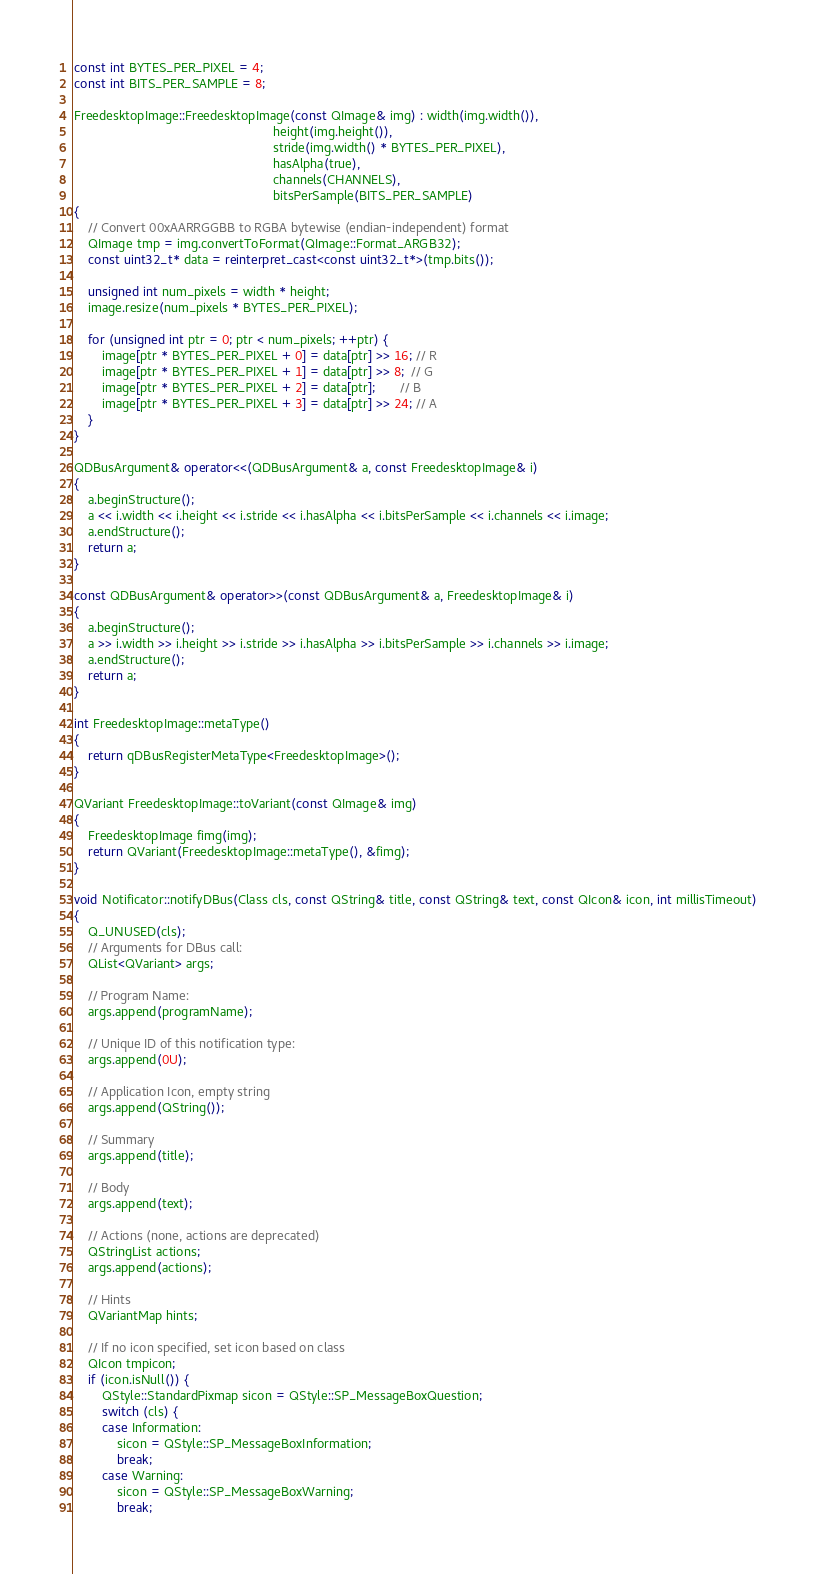Convert code to text. <code><loc_0><loc_0><loc_500><loc_500><_C++_>const int BYTES_PER_PIXEL = 4;
const int BITS_PER_SAMPLE = 8;

FreedesktopImage::FreedesktopImage(const QImage& img) : width(img.width()),
                                                        height(img.height()),
                                                        stride(img.width() * BYTES_PER_PIXEL),
                                                        hasAlpha(true),
                                                        channels(CHANNELS),
                                                        bitsPerSample(BITS_PER_SAMPLE)
{
    // Convert 00xAARRGGBB to RGBA bytewise (endian-independent) format
    QImage tmp = img.convertToFormat(QImage::Format_ARGB32);
    const uint32_t* data = reinterpret_cast<const uint32_t*>(tmp.bits());

    unsigned int num_pixels = width * height;
    image.resize(num_pixels * BYTES_PER_PIXEL);

    for (unsigned int ptr = 0; ptr < num_pixels; ++ptr) {
        image[ptr * BYTES_PER_PIXEL + 0] = data[ptr] >> 16; // R
        image[ptr * BYTES_PER_PIXEL + 1] = data[ptr] >> 8;  // G
        image[ptr * BYTES_PER_PIXEL + 2] = data[ptr];       // B
        image[ptr * BYTES_PER_PIXEL + 3] = data[ptr] >> 24; // A
    }
}

QDBusArgument& operator<<(QDBusArgument& a, const FreedesktopImage& i)
{
    a.beginStructure();
    a << i.width << i.height << i.stride << i.hasAlpha << i.bitsPerSample << i.channels << i.image;
    a.endStructure();
    return a;
}

const QDBusArgument& operator>>(const QDBusArgument& a, FreedesktopImage& i)
{
    a.beginStructure();
    a >> i.width >> i.height >> i.stride >> i.hasAlpha >> i.bitsPerSample >> i.channels >> i.image;
    a.endStructure();
    return a;
}

int FreedesktopImage::metaType()
{
    return qDBusRegisterMetaType<FreedesktopImage>();
}

QVariant FreedesktopImage::toVariant(const QImage& img)
{
    FreedesktopImage fimg(img);
    return QVariant(FreedesktopImage::metaType(), &fimg);
}

void Notificator::notifyDBus(Class cls, const QString& title, const QString& text, const QIcon& icon, int millisTimeout)
{
    Q_UNUSED(cls);
    // Arguments for DBus call:
    QList<QVariant> args;

    // Program Name:
    args.append(programName);

    // Unique ID of this notification type:
    args.append(0U);

    // Application Icon, empty string
    args.append(QString());

    // Summary
    args.append(title);

    // Body
    args.append(text);

    // Actions (none, actions are deprecated)
    QStringList actions;
    args.append(actions);

    // Hints
    QVariantMap hints;

    // If no icon specified, set icon based on class
    QIcon tmpicon;
    if (icon.isNull()) {
        QStyle::StandardPixmap sicon = QStyle::SP_MessageBoxQuestion;
        switch (cls) {
        case Information:
            sicon = QStyle::SP_MessageBoxInformation;
            break;
        case Warning:
            sicon = QStyle::SP_MessageBoxWarning;
            break;</code> 